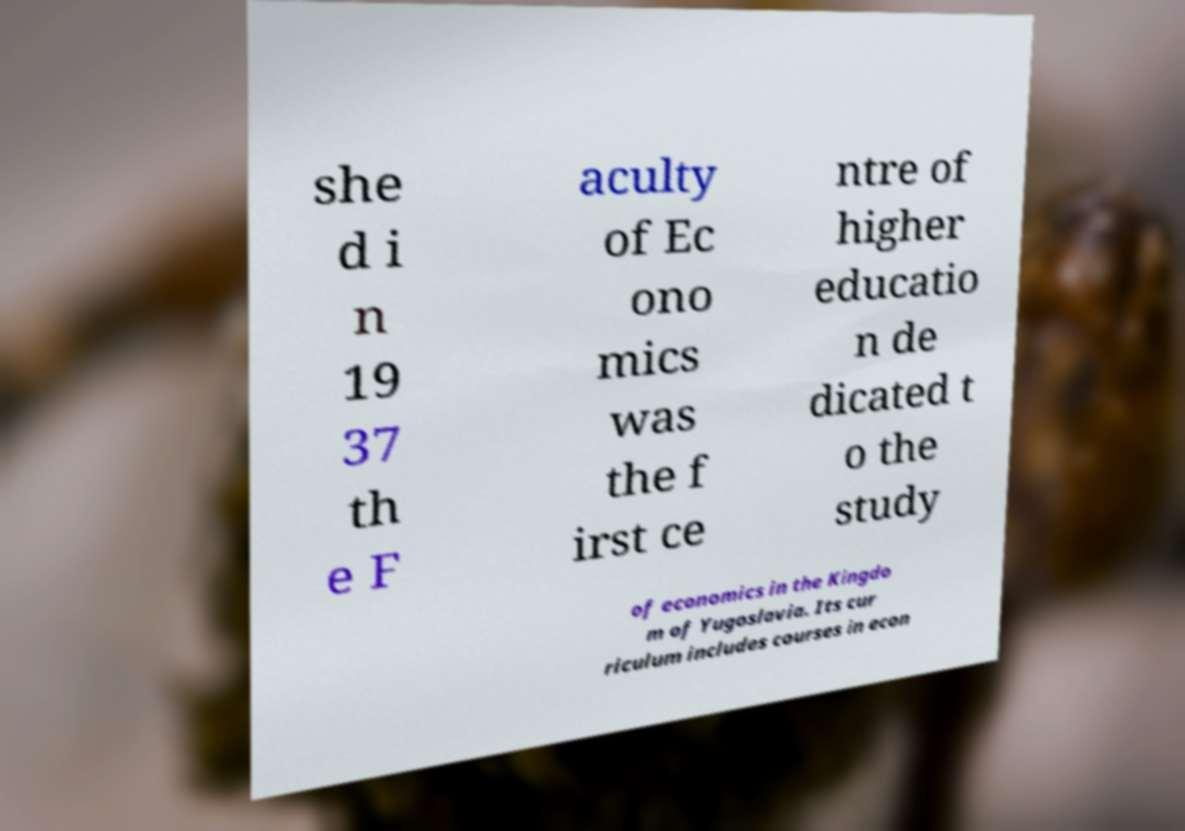Could you assist in decoding the text presented in this image and type it out clearly? she d i n 19 37 th e F aculty of Ec ono mics was the f irst ce ntre of higher educatio n de dicated t o the study of economics in the Kingdo m of Yugoslavia. Its cur riculum includes courses in econ 